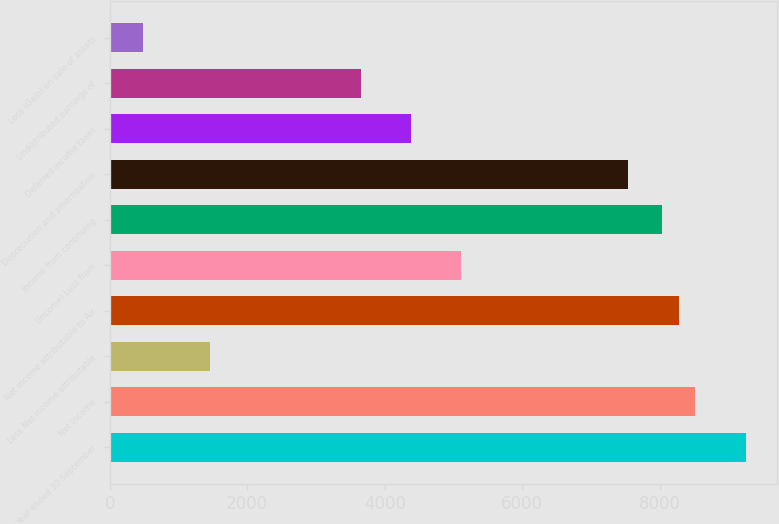<chart> <loc_0><loc_0><loc_500><loc_500><bar_chart><fcel>Year ended 30 September<fcel>Net Income<fcel>Less Net income attributable<fcel>Net income attributable to Air<fcel>(Income) Loss from<fcel>Income from continuing<fcel>Depreciation and amortization<fcel>Deferred income taxes<fcel>Undistributed earnings of<fcel>Loss (Gain) on sale of assets<nl><fcel>9250.12<fcel>8519.95<fcel>1461.64<fcel>8276.56<fcel>5112.49<fcel>8033.17<fcel>7546.39<fcel>4382.32<fcel>3652.15<fcel>488.08<nl></chart> 